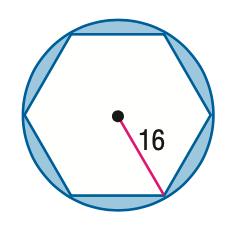Answer the mathemtical geometry problem and directly provide the correct option letter.
Question: Find the area of the shaded region. Assume that the polygon is regular unless otherwise stated. Round to the nearest tenth.
Choices: A: 139.1 B: 516.2 C: 721.1 D: 762.7 A 